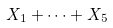<formula> <loc_0><loc_0><loc_500><loc_500>X _ { 1 } + \dots + X _ { 5 }</formula> 